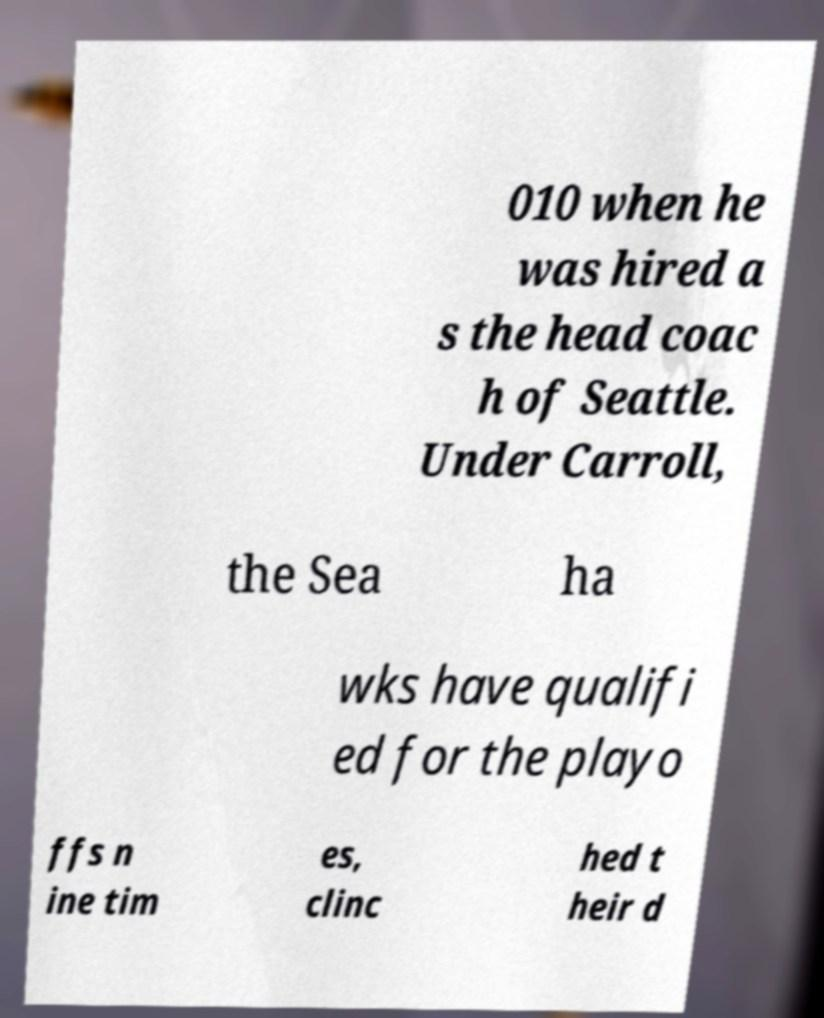Can you read and provide the text displayed in the image?This photo seems to have some interesting text. Can you extract and type it out for me? 010 when he was hired a s the head coac h of Seattle. Under Carroll, the Sea ha wks have qualifi ed for the playo ffs n ine tim es, clinc hed t heir d 